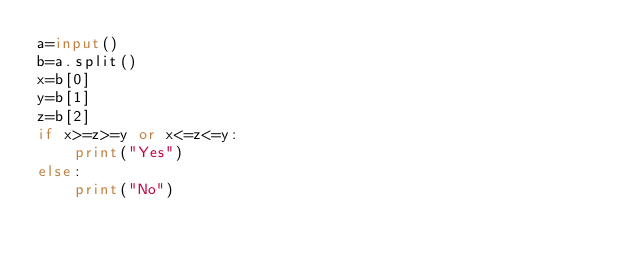Convert code to text. <code><loc_0><loc_0><loc_500><loc_500><_Python_>a=input()
b=a.split()
x=b[0]
y=b[1]
z=b[2]
if x>=z>=y or x<=z<=y:
    print("Yes")
else:
    print("No")
</code> 